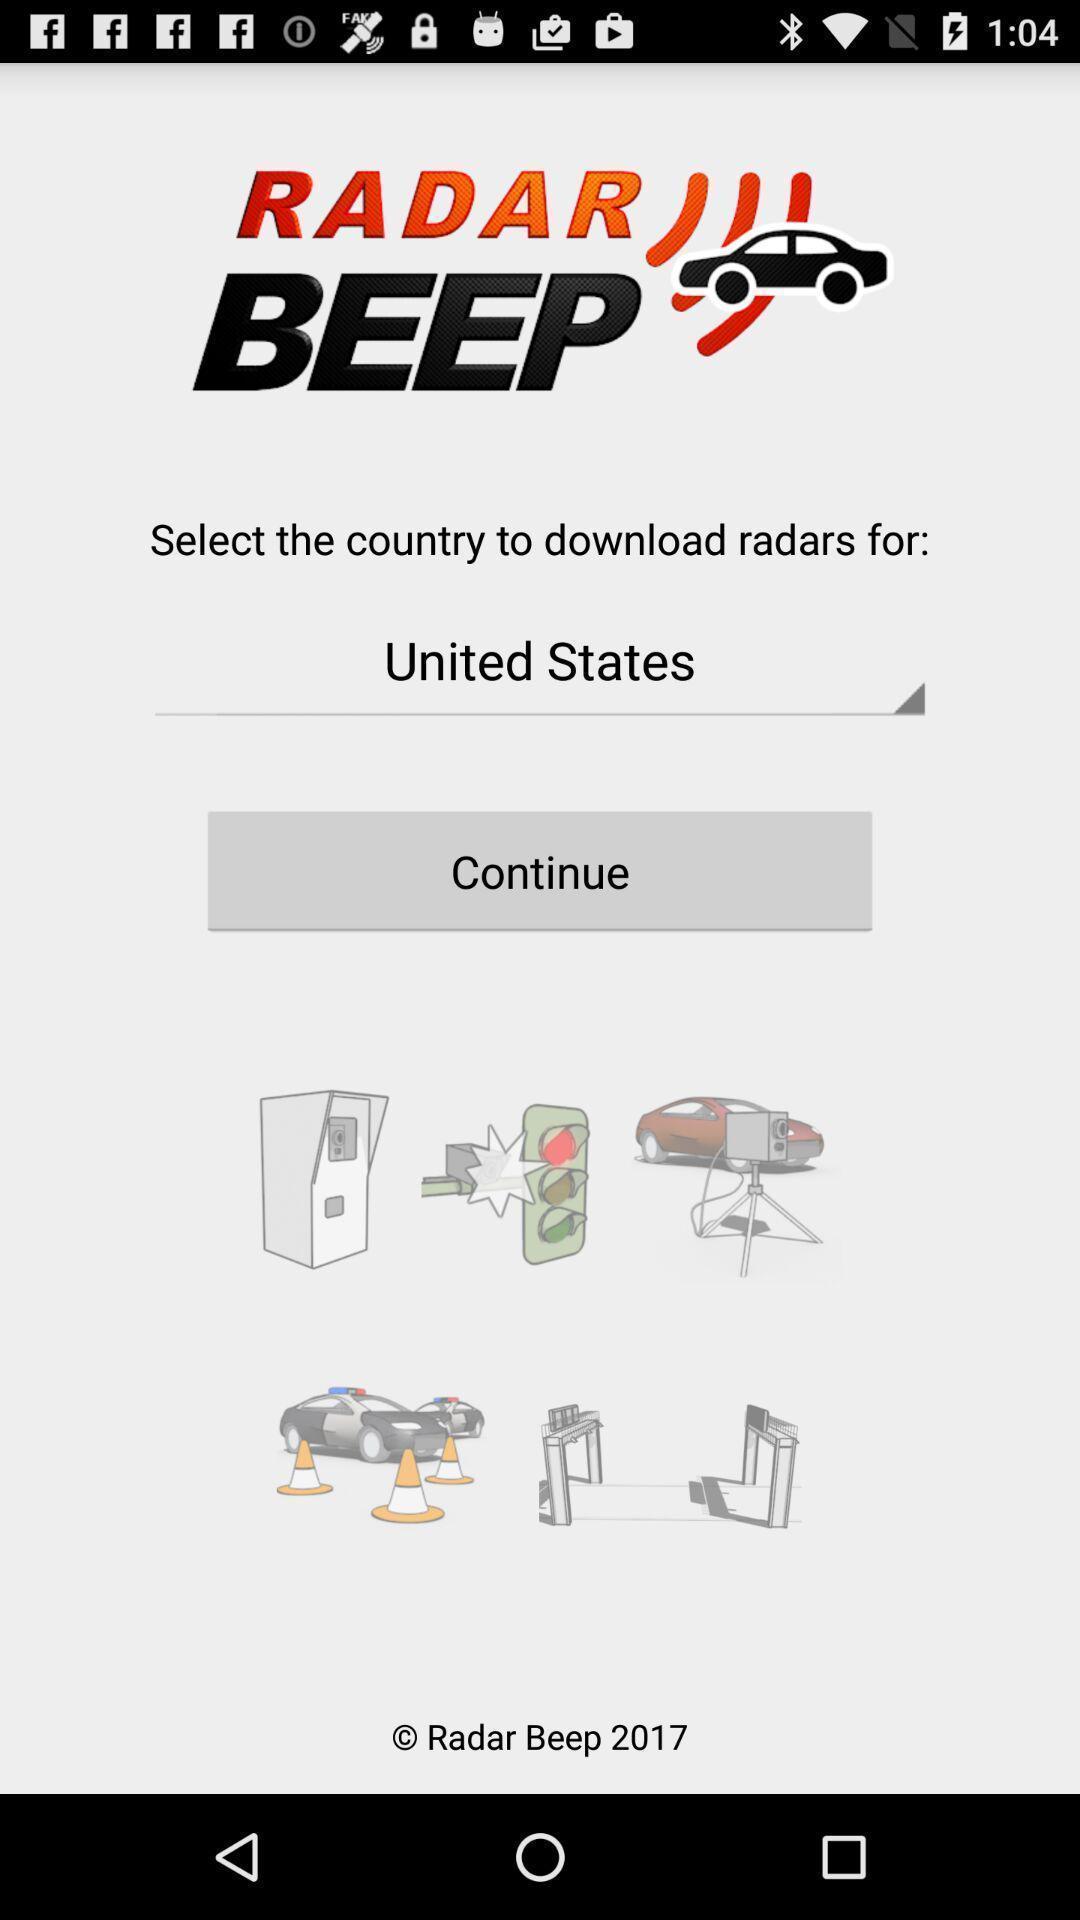Describe the key features of this screenshot. Starting page of a radar detecting app. 